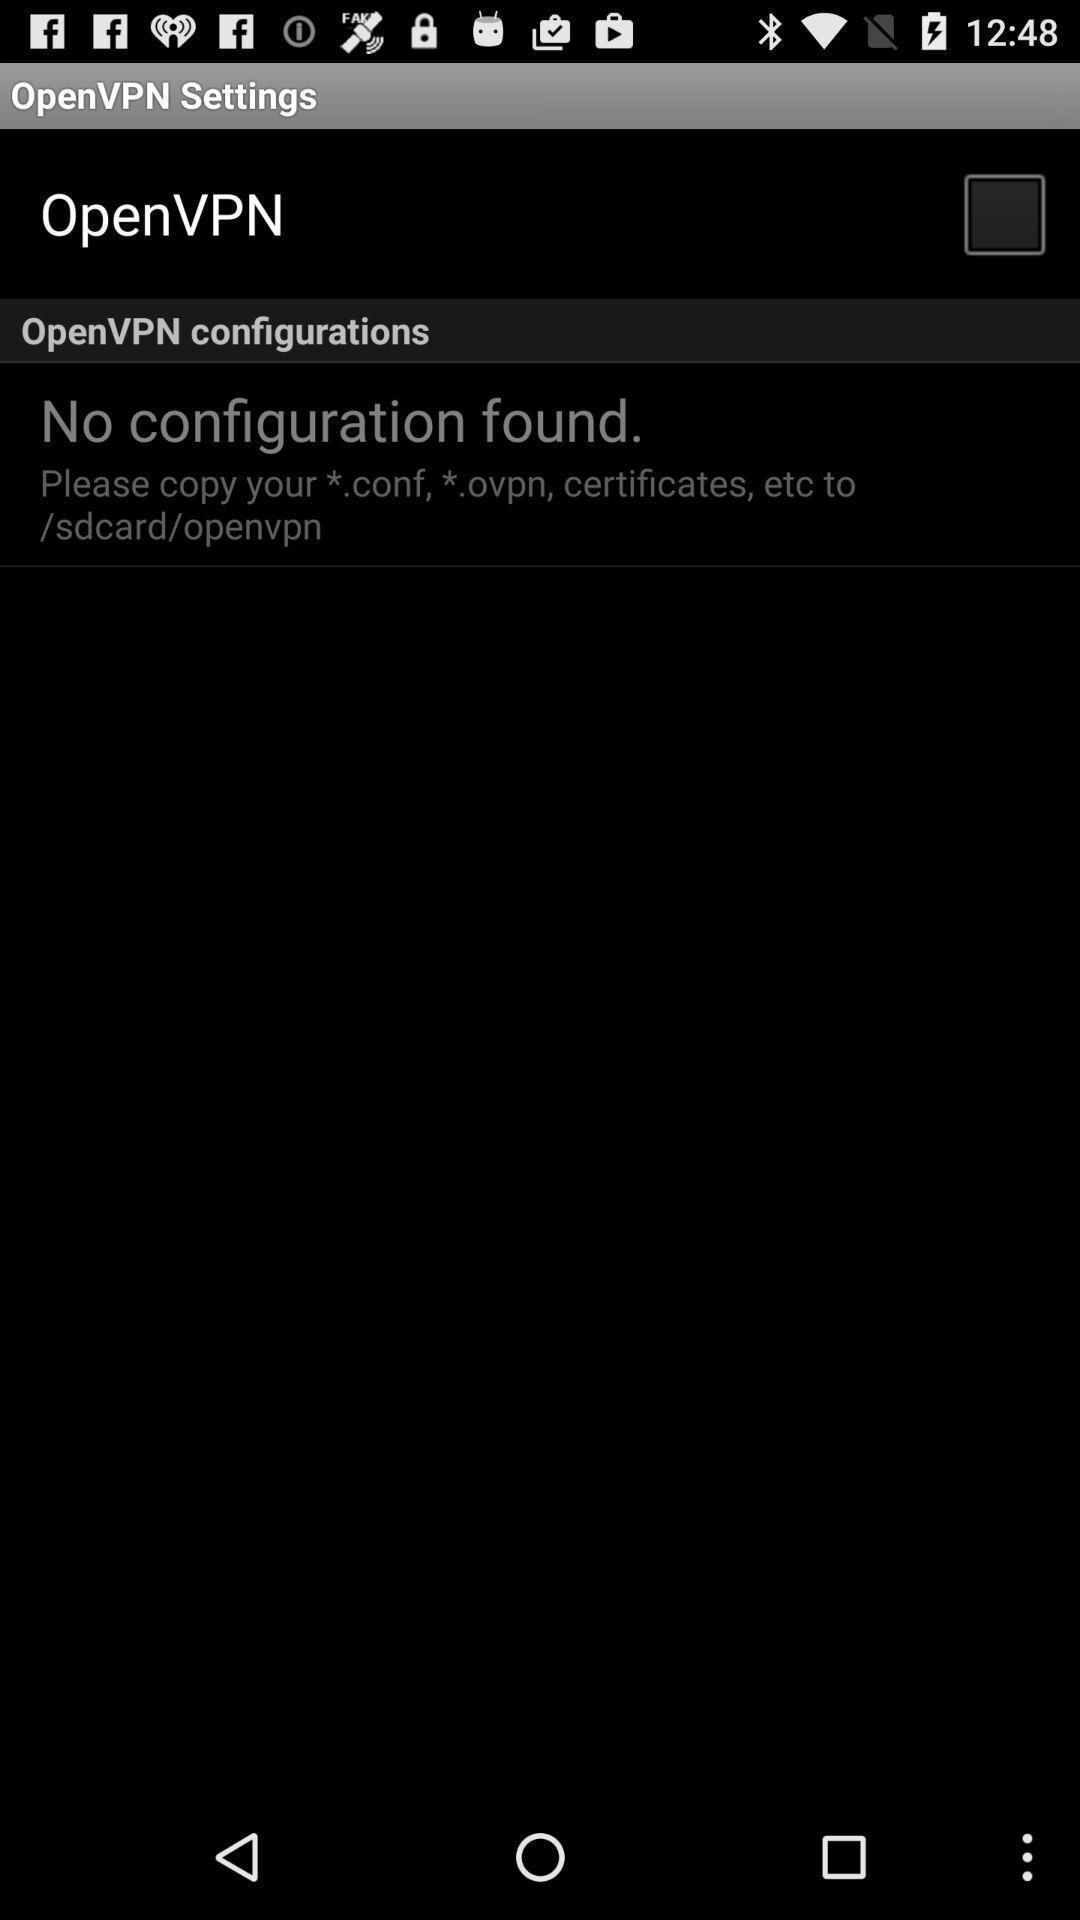Provide a description of this screenshot. Settings page. 